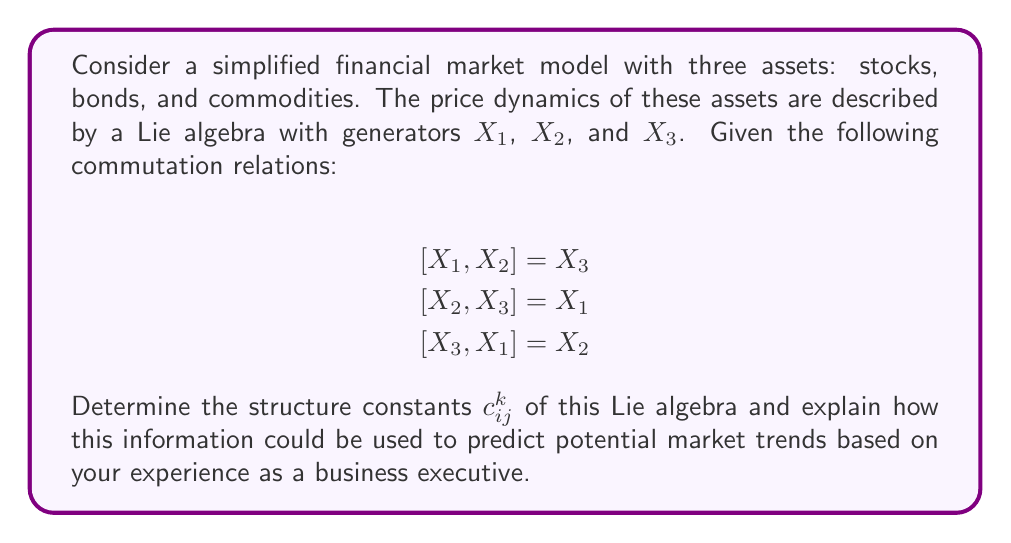Can you answer this question? To solve this problem, we need to follow these steps:

1) Recall that the structure constants $c_{ij}^k$ are defined by the commutation relations:

   $$[X_i, X_j] = \sum_k c_{ij}^k X_k$$

2) From the given commutation relations, we can identify the non-zero structure constants:

   $[X_1, X_2] = X_3$ implies $c_{12}^3 = 1$
   $[X_2, X_3] = X_1$ implies $c_{23}^1 = 1$
   $[X_3, X_1] = X_2$ implies $c_{31}^2 = 1$

3) Note that the structure constants are antisymmetric in the lower indices:

   $c_{ij}^k = -c_{ji}^k$

   This means:
   $c_{21}^3 = -1$
   $c_{32}^1 = -1$
   $c_{13}^2 = -1$

4) All other structure constants are zero.

5) The structure of this Lie algebra is that of $\mathfrak{so}(3)$, the special orthogonal Lie algebra in three dimensions. This is isomorphic to $\mathfrak{su}(2)$, which often appears in physics and can model rotations in three-dimensional space.

From a business perspective, this Lie algebra structure suggests a cyclical relationship between the three asset classes. The commutation relations indicate that changes in one asset class can induce rotations or shifts in the other two. 

For example, $[X_1, X_2] = X_3$ could be interpreted as interactions between stocks and bonds influencing commodities. This aligns with real-world observations where, for instance, changes in interest rates (affecting bonds) and corporate performance (affecting stocks) can impact commodity prices.

The cyclic nature of the relations ($1 \rightarrow 2 \rightarrow 3 \rightarrow 1$) suggests that market trends might follow a rotating pattern among these asset classes. As a business executive, you might use this insight to anticipate that after a period of stock market dominance, there could be a shift towards bond market activity, followed by increased action in commodities, before cycling back to stocks.

However, it's crucial to note that this is a simplified model. Real financial markets are far more complex, with many more variables and non-linear interactions. This model provides a framework for understanding some basic interrelationships, but should be complemented with other analysis tools and real-world experience for comprehensive market prediction.
Answer: The non-zero structure constants are:
$c_{12}^3 = 1$, $c_{23}^1 = 1$, $c_{31}^2 = 1$
$c_{21}^3 = -1$, $c_{32}^1 = -1$, $c_{13}^2 = -1$
All other $c_{ij}^k = 0$

This Lie algebra structure suggests cyclical relationships between asset classes, which could indicate rotating market trends among stocks, bonds, and commodities. 